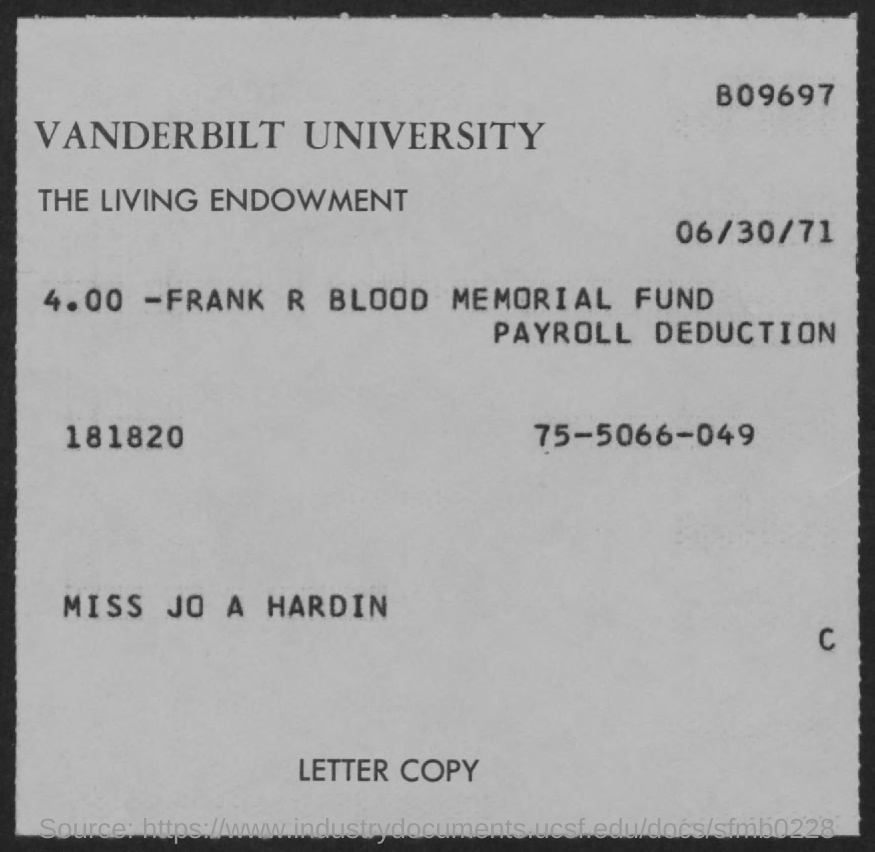What is the date mentioned in the document?
Your answer should be very brief. 06/30/71. What is the first title in the document?
Provide a short and direct response. Vanderbilt university. 